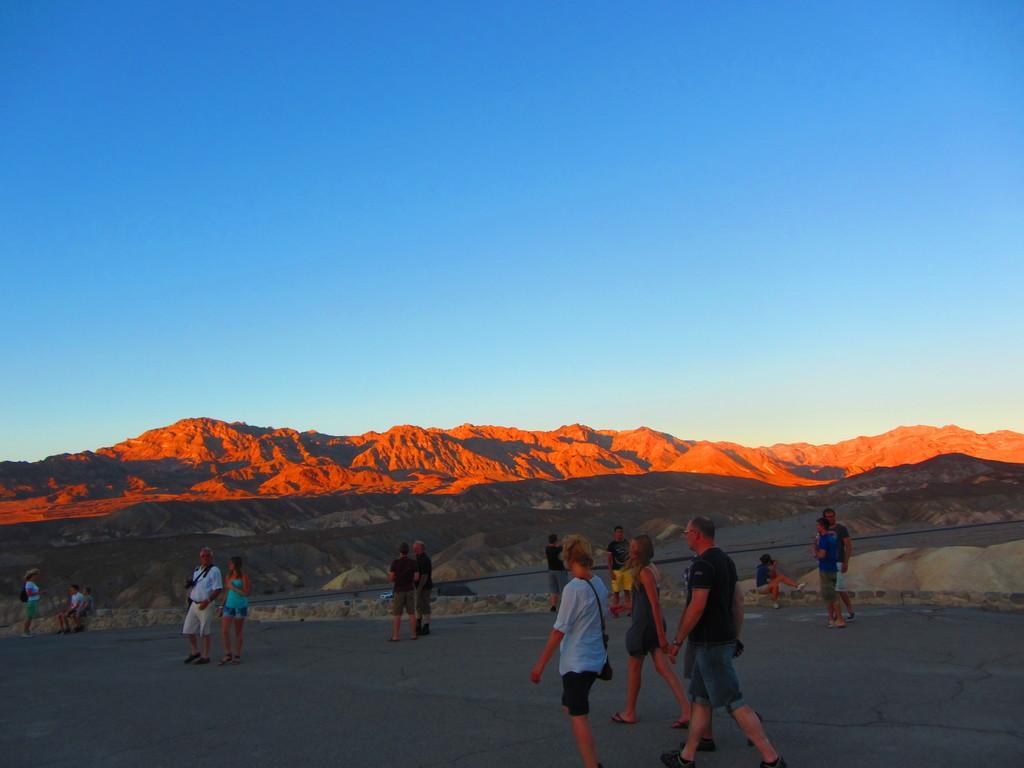Could you give a brief overview of what you see in this image? In this image I can see number of people where few are sitting and rest all are standing. In the background I can see mountains and the sky. 